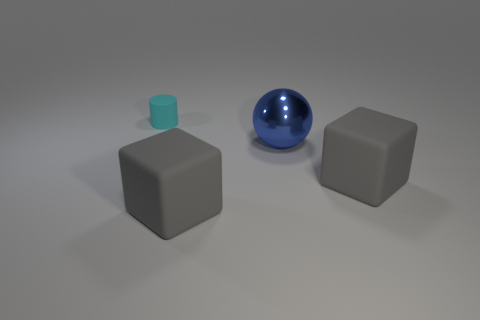Add 4 tiny gray blocks. How many objects exist? 8 Subtract all cylinders. How many objects are left? 3 Subtract 1 spheres. How many spheres are left? 0 Subtract all green balls. Subtract all brown cylinders. How many balls are left? 1 Subtract all metal objects. Subtract all small rubber objects. How many objects are left? 2 Add 3 small matte objects. How many small matte objects are left? 4 Add 3 gray matte things. How many gray matte things exist? 5 Subtract 0 yellow blocks. How many objects are left? 4 